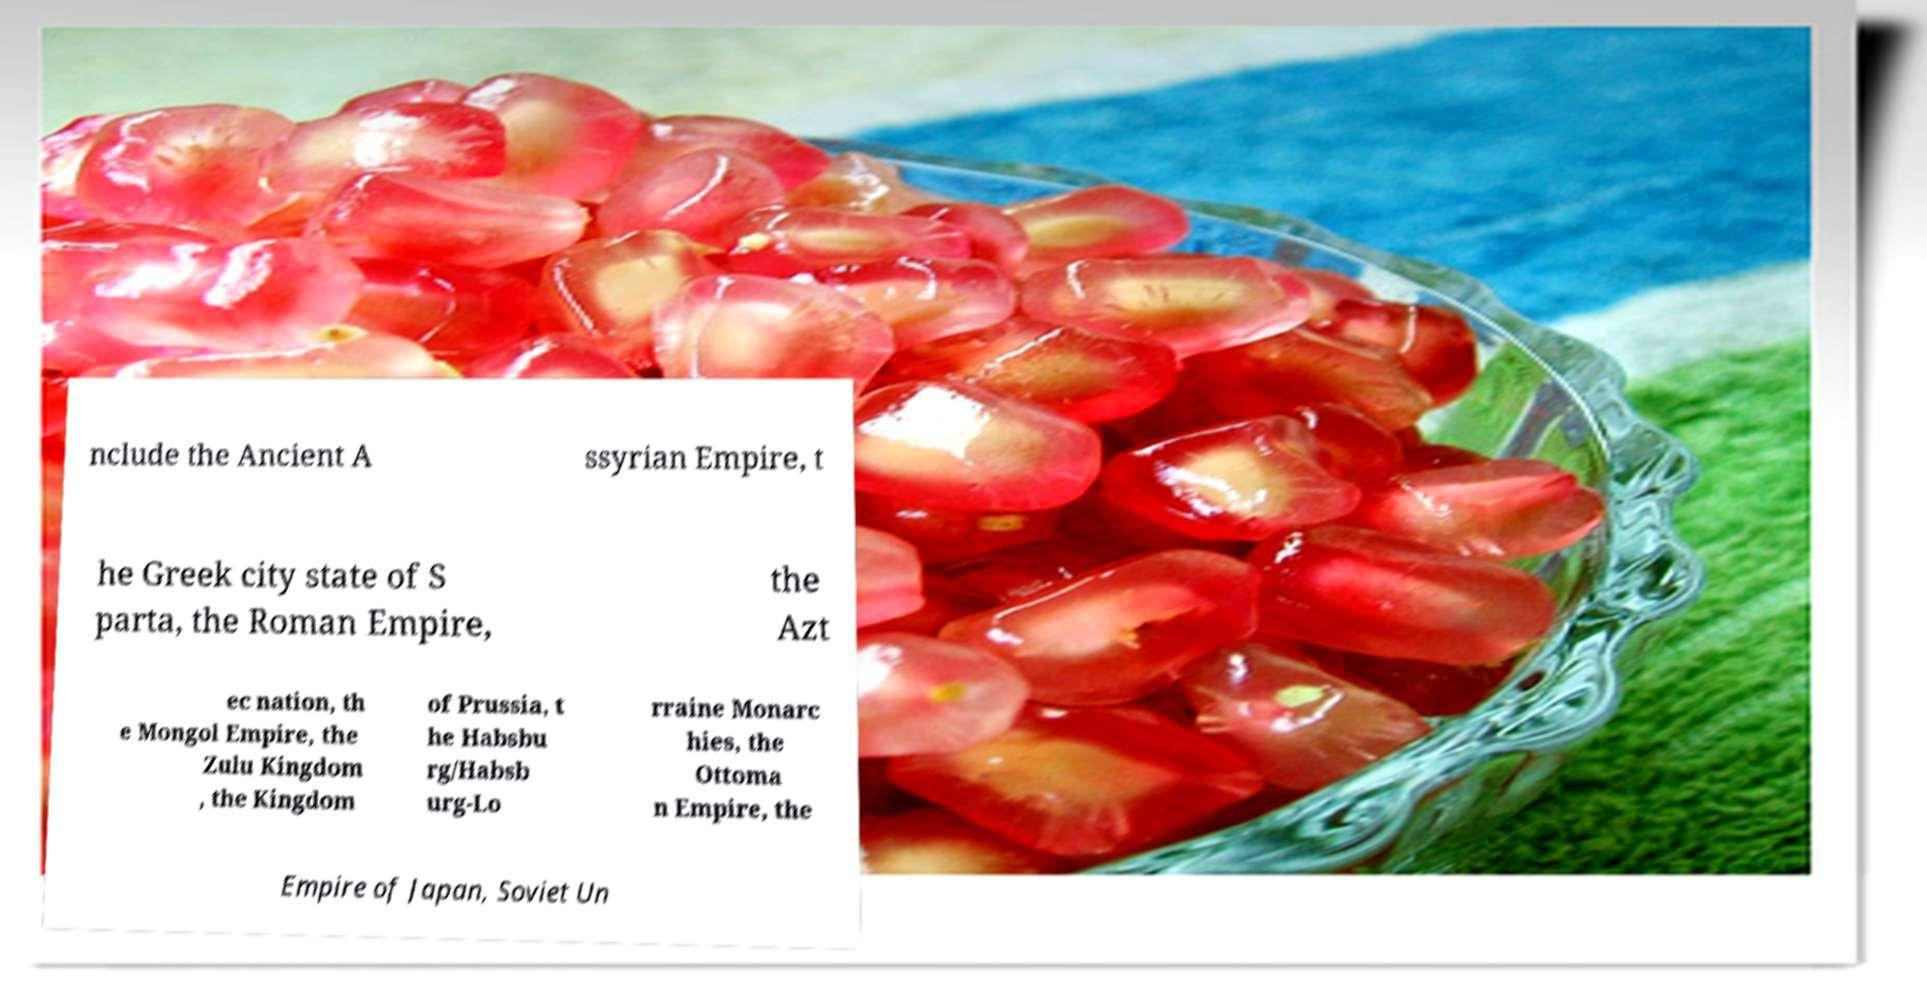Can you accurately transcribe the text from the provided image for me? nclude the Ancient A ssyrian Empire, t he Greek city state of S parta, the Roman Empire, the Azt ec nation, th e Mongol Empire, the Zulu Kingdom , the Kingdom of Prussia, t he Habsbu rg/Habsb urg-Lo rraine Monarc hies, the Ottoma n Empire, the Empire of Japan, Soviet Un 